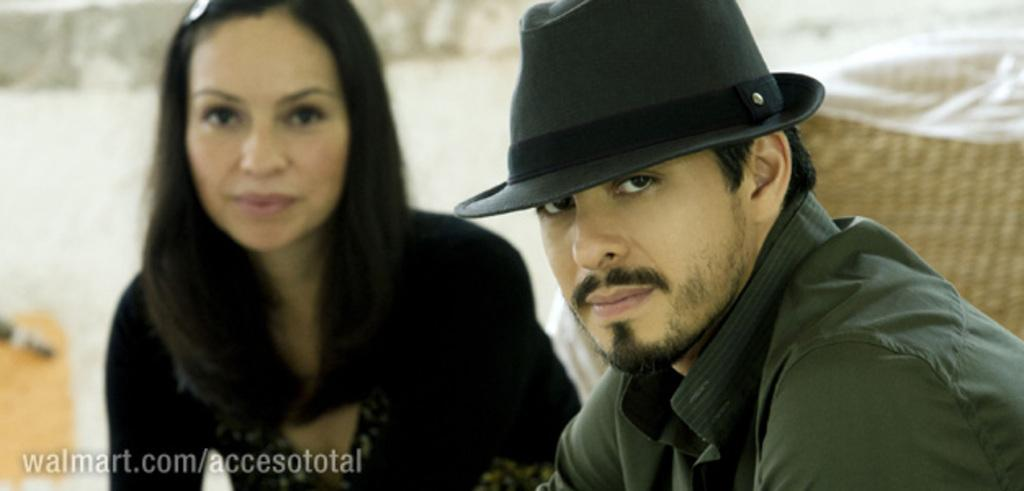How many people are in the image? There are two people in the image, a man and a woman. What is the man wearing on his head? The man is wearing a cap. Can you describe the background of the image? The background of the image is blurry. Is there any text visible in the image? Yes, there is some text at the left bottom of the image. How many ducks are visible in the image? There are no ducks present in the image. What type of bells can be heard ringing in the image? There is no sound or indication of bells in the image. 